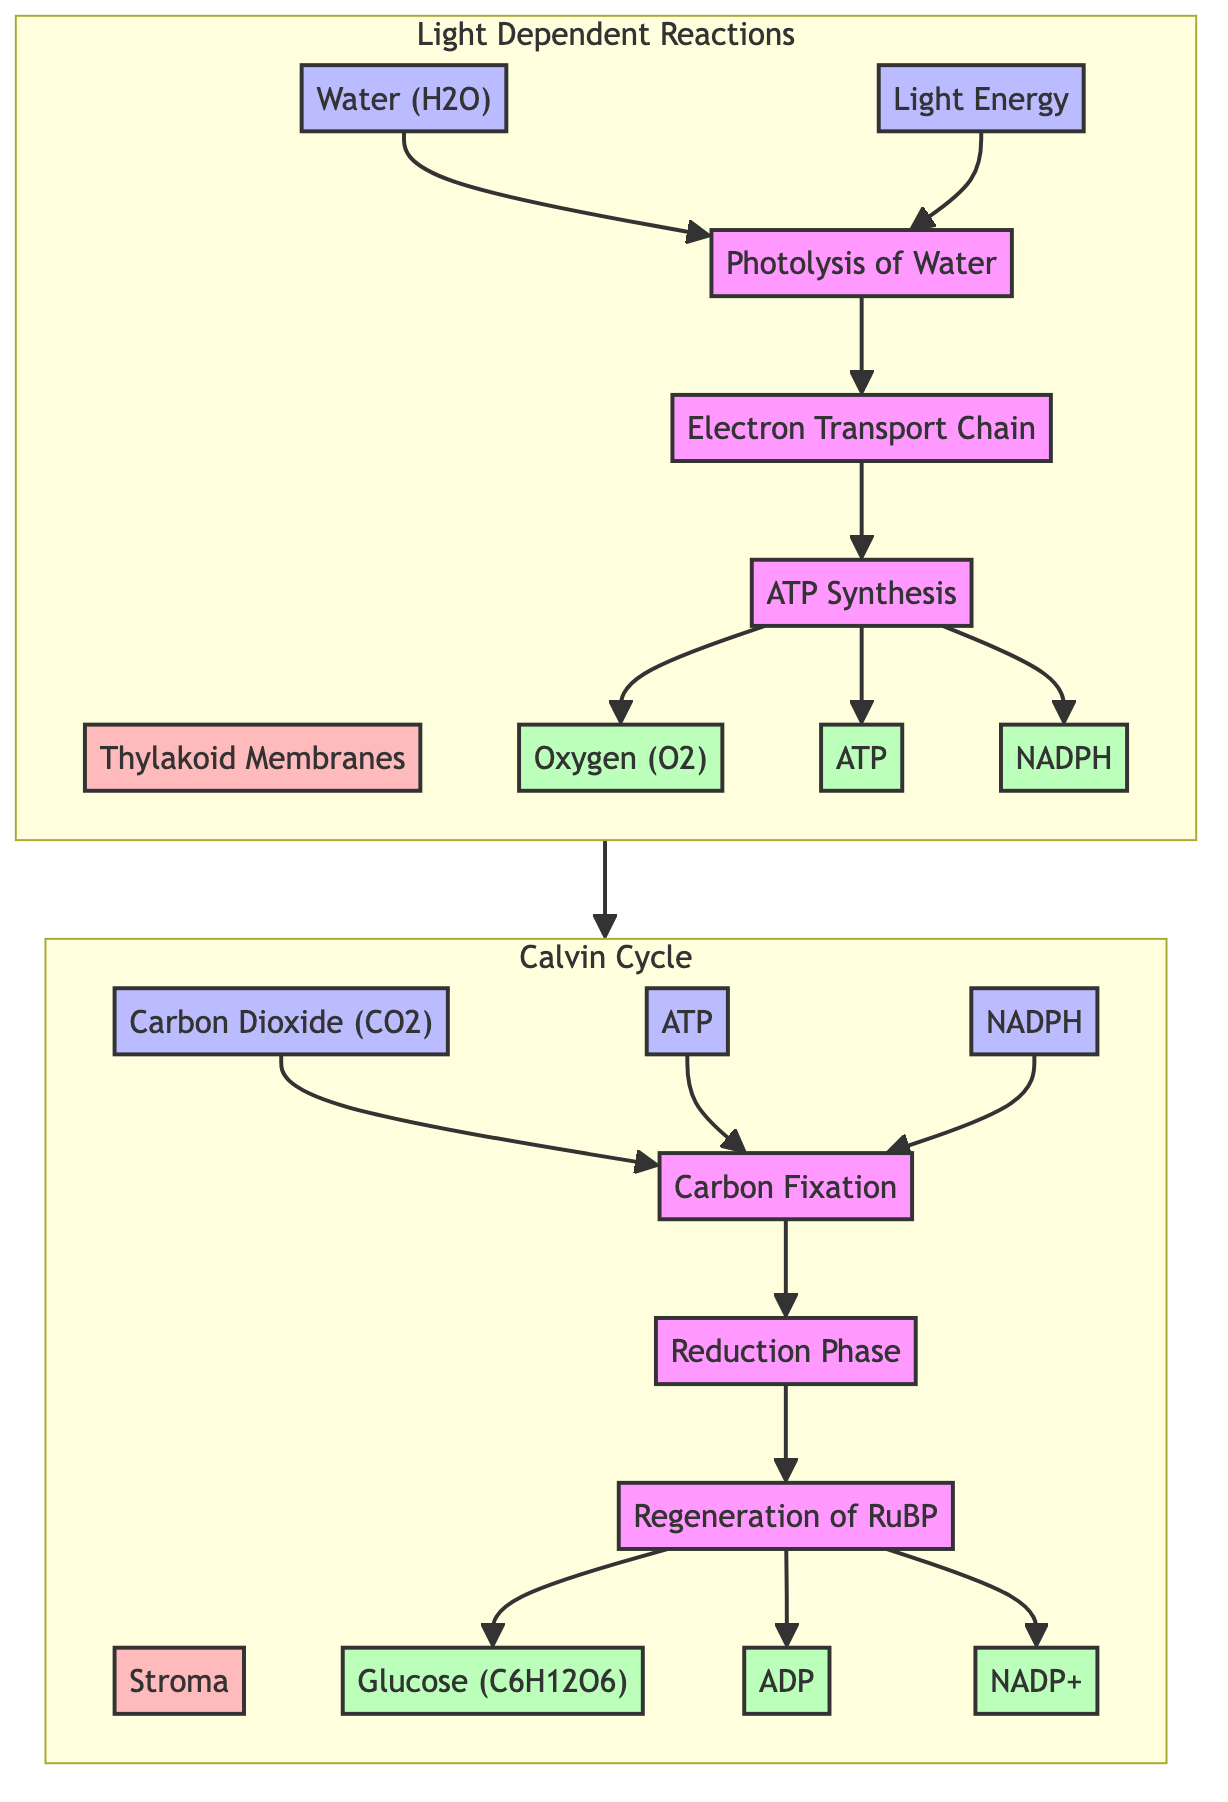What is the location of Light Dependent Reactions? The diagram indicates that the Light Dependent Reactions take place in the Thylakoid Membranes of Chloroplasts. This information is labeled specifically in the Light Dependent Reactions section.
Answer: Thylakoid Membranes of Chloroplasts What are the outputs of the Calvin Cycle? According to the diagram under the Calvin Cycle section, the outputs are Glucose, Adenosine Diphosphate, and Nicotinamide Adenine Dinucleotide Phosphate. Each output is specifically mentioned below the processes involved in the Calvin Cycle.
Answer: Glucose, Adenosine Diphosphate, Nicotinamide Adenine Dinucleotide Phosphate How many inputs are there in the Calvin Cycle? The diagram shows three inputs in the Calvin Cycle section: Carbon Dioxide, ATP, and NADPH. By counting these specific inputs listed, we can determine the total.
Answer: 3 What is the first process in Light Dependent Reactions? In the flow of the Light Dependent Reactions, the first process listed is the Photolysis of Water. This is identified clearly as the initial step in the process chain.
Answer: Photolysis of Water Which type of energy is used in Light Dependent Reactions? The diagram indicates that Light Energy is one of the inputs in the Light Dependent Reactions. It is categorized as an input specifically in this part of the flowchart.
Answer: Light Energy What outputs are generated after the Electron Transport Chain? From the diagram, after the Electron Transport Chain process in the Light Dependent Reactions, the outputs generated are Oxygen, ATP, and NADPH. These are clearly shown as resulting outputs from the preceding processes.
Answer: Oxygen, ATP, NADPH Which process immediately follows Carbon Fixation in the Calvin Cycle? The diagram illustrates that the process that follows Carbon Fixation in the Calvin Cycle is the Reduction Phase. This sequential flow of processes provides clarity on the order of operations within this cycle.
Answer: Reduction Phase What connects the Light Dependent Reactions to the Calvin Cycle? The diagram shows an arrow connecting the Light Dependent Reactions to the Calvin Cycle, indicating the flow of outputs from the Light Dependent Reactions that serve as inputs to the Calvin Cycle.
Answer: Outputs from Light Dependent Reactions How many phases are there in the Calvin Cycle? The diagram indicates three phases within the Calvin Cycle section: Carbon Fixation, Reduction Phase, and Regeneration of RuBP. By counting these phases listed, we establish the total.
Answer: 3 